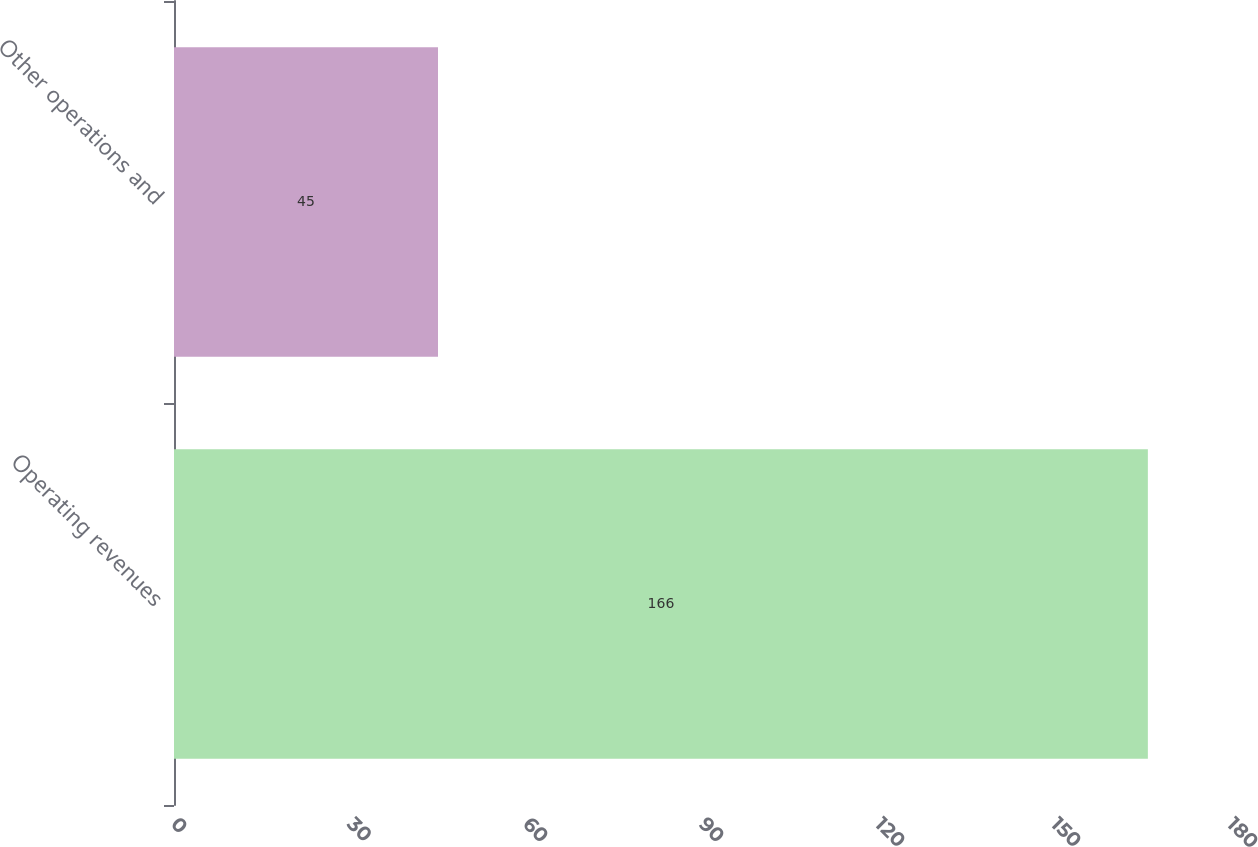<chart> <loc_0><loc_0><loc_500><loc_500><bar_chart><fcel>Operating revenues<fcel>Other operations and<nl><fcel>166<fcel>45<nl></chart> 